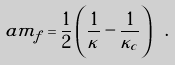<formula> <loc_0><loc_0><loc_500><loc_500>a m _ { f } = \frac { 1 } { 2 } \left ( \frac { 1 } { \kappa } - \frac { 1 } { \kappa _ { c } } \right ) \ .</formula> 